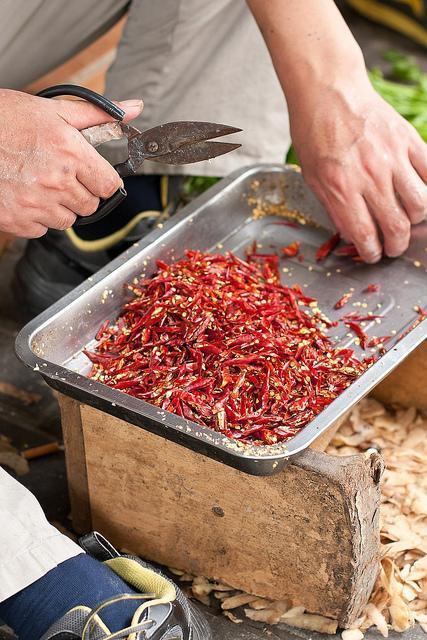How many people are in the photo?
Give a very brief answer. 2. 